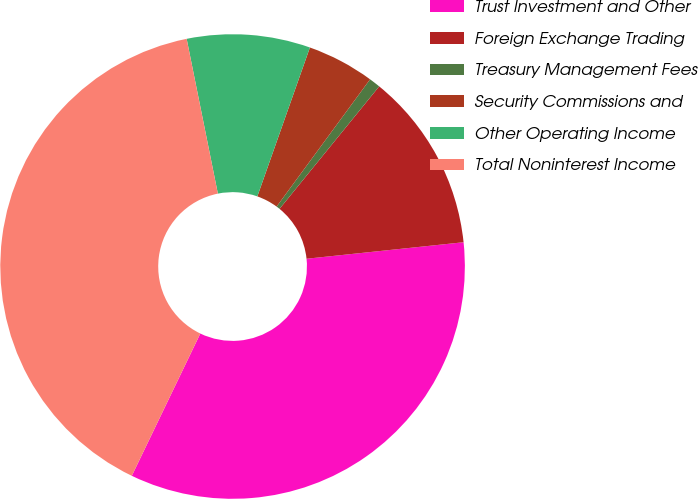Convert chart to OTSL. <chart><loc_0><loc_0><loc_500><loc_500><pie_chart><fcel>Trust Investment and Other<fcel>Foreign Exchange Trading<fcel>Treasury Management Fees<fcel>Security Commissions and<fcel>Other Operating Income<fcel>Total Noninterest Income<nl><fcel>33.81%<fcel>12.46%<fcel>0.79%<fcel>4.68%<fcel>8.57%<fcel>39.69%<nl></chart> 